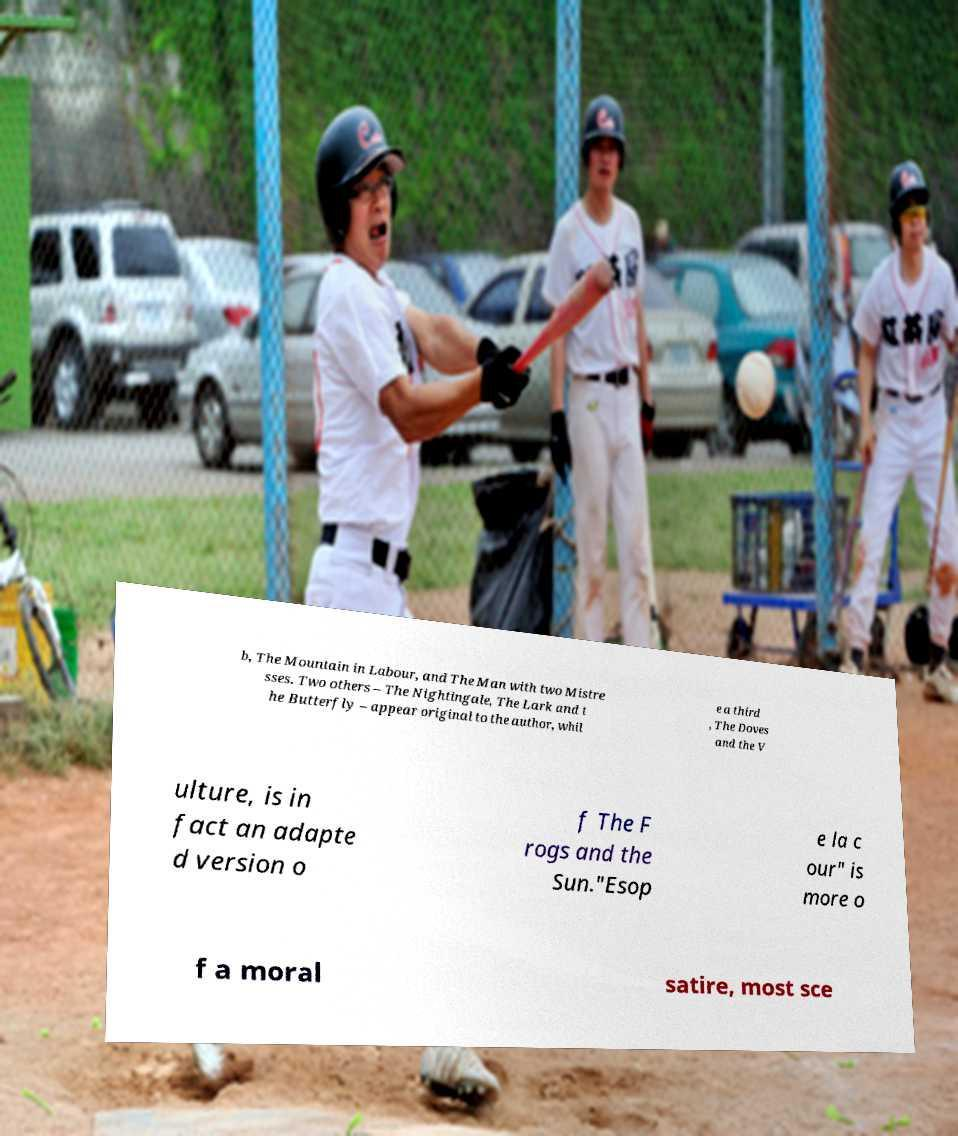Can you read and provide the text displayed in the image?This photo seems to have some interesting text. Can you extract and type it out for me? b, The Mountain in Labour, and The Man with two Mistre sses. Two others – The Nightingale, The Lark and t he Butterfly – appear original to the author, whil e a third , The Doves and the V ulture, is in fact an adapte d version o f The F rogs and the Sun."Esop e la c our" is more o f a moral satire, most sce 